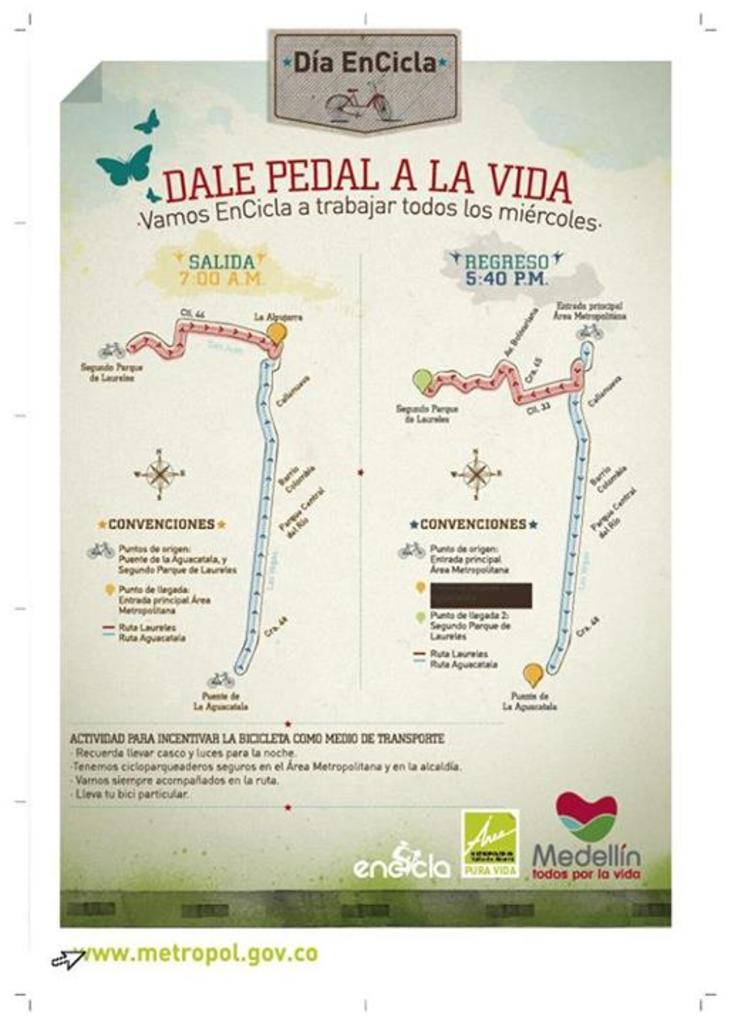<image>
Share a concise interpretation of the image provided. A sheet of paper with Dia EnVicla at the top 